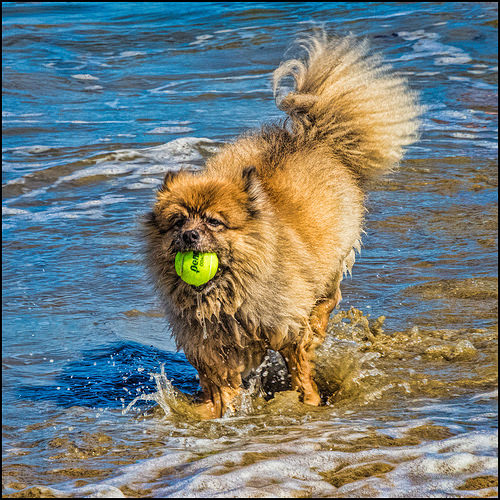<image>
Can you confirm if the ball is above the water? Yes. The ball is positioned above the water in the vertical space, higher up in the scene. 